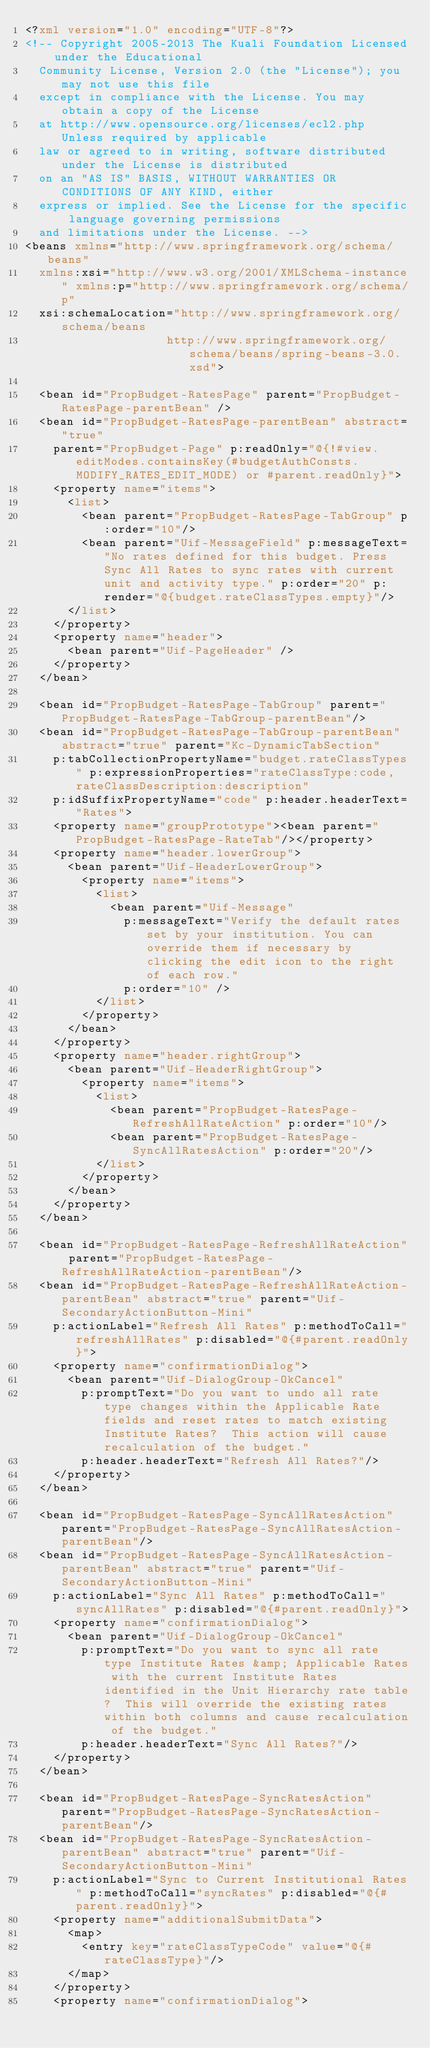Convert code to text. <code><loc_0><loc_0><loc_500><loc_500><_XML_><?xml version="1.0" encoding="UTF-8"?>
<!-- Copyright 2005-2013 The Kuali Foundation Licensed under the Educational 
	Community License, Version 2.0 (the "License"); you may not use this file 
	except in compliance with the License. You may obtain a copy of the License 
	at http://www.opensource.org/licenses/ecl2.php Unless required by applicable 
	law or agreed to in writing, software distributed under the License is distributed 
	on an "AS IS" BASIS, WITHOUT WARRANTIES OR CONDITIONS OF ANY KIND, either 
	express or implied. See the License for the specific language governing permissions 
	and limitations under the License. -->
<beans xmlns="http://www.springframework.org/schema/beans"
	xmlns:xsi="http://www.w3.org/2001/XMLSchema-instance" xmlns:p="http://www.springframework.org/schema/p"
	xsi:schemaLocation="http://www.springframework.org/schema/beans
                    http://www.springframework.org/schema/beans/spring-beans-3.0.xsd">

	<bean id="PropBudget-RatesPage" parent="PropBudget-RatesPage-parentBean" />
	<bean id="PropBudget-RatesPage-parentBean" abstract="true"
		parent="PropBudget-Page" p:readOnly="@{!#view.editModes.containsKey(#budgetAuthConsts.MODIFY_RATES_EDIT_MODE) or #parent.readOnly}">
		<property name="items">
			<list>
				<bean parent="PropBudget-RatesPage-TabGroup" p:order="10"/>
				<bean parent="Uif-MessageField" p:messageText="No rates defined for this budget. Press Sync All Rates to sync rates with current unit and activity type." p:order="20" p:render="@{budget.rateClassTypes.empty}"/>
			</list>
		</property>
		<property name="header">
			<bean parent="Uif-PageHeader" />
		</property>
	</bean>

	<bean id="PropBudget-RatesPage-TabGroup" parent="PropBudget-RatesPage-TabGroup-parentBean"/>
	<bean id="PropBudget-RatesPage-TabGroup-parentBean" abstract="true" parent="Kc-DynamicTabSection"
		p:tabCollectionPropertyName="budget.rateClassTypes" p:expressionProperties="rateClassType:code,rateClassDescription:description"
		p:idSuffixPropertyName="code" p:header.headerText="Rates">
		<property name="groupPrototype"><bean parent="PropBudget-RatesPage-RateTab"/></property>
		<property name="header.lowerGroup">
			<bean parent="Uif-HeaderLowerGroup">
				<property name="items">
					<list>
						<bean parent="Uif-Message"
							p:messageText="Verify the default rates set by your institution. You can override them if necessary by clicking the edit icon to the right of each row."
							p:order="10" />
					</list>
				</property>
			</bean>
		</property>
		<property name="header.rightGroup">
			<bean parent="Uif-HeaderRightGroup">
				<property name="items">
					<list>
						<bean parent="PropBudget-RatesPage-RefreshAllRateAction" p:order="10"/>
						<bean parent="PropBudget-RatesPage-SyncAllRatesAction" p:order="20"/>
					</list>
				</property>
			</bean>
		</property>		
	</bean>
	
	<bean id="PropBudget-RatesPage-RefreshAllRateAction" parent="PropBudget-RatesPage-RefreshAllRateAction-parentBean"/>
	<bean id="PropBudget-RatesPage-RefreshAllRateAction-parentBean" abstract="true" parent="Uif-SecondaryActionButton-Mini" 
		p:actionLabel="Refresh All Rates" p:methodToCall="refreshAllRates" p:disabled="@{#parent.readOnly}">
		<property name="confirmationDialog">
			<bean parent="Uif-DialogGroup-OkCancel"
				p:promptText="Do you want to undo all rate type changes within the Applicable Rate fields and reset rates to match existing Institute Rates?  This action will cause recalculation of the budget."
				p:header.headerText="Refresh All Rates?"/>
		</property>
	</bean>
	
	<bean id="PropBudget-RatesPage-SyncAllRatesAction" parent="PropBudget-RatesPage-SyncAllRatesAction-parentBean"/>
	<bean id="PropBudget-RatesPage-SyncAllRatesAction-parentBean" abstract="true" parent="Uif-SecondaryActionButton-Mini" 
		p:actionLabel="Sync All Rates" p:methodToCall="syncAllRates" p:disabled="@{#parent.readOnly}">
		<property name="confirmationDialog">
			<bean parent="Uif-DialogGroup-OkCancel" 
				p:promptText="Do you want to sync all rate type Institute Rates &amp; Applicable Rates with the current Institute Rates identified in the Unit Hierarchy rate table?  This will override the existing rates within both columns and cause recalculation of the budget."
				p:header.headerText="Sync All Rates?"/>
		</property>							
	</bean>
	
	<bean id="PropBudget-RatesPage-SyncRatesAction" parent="PropBudget-RatesPage-SyncRatesAction-parentBean"/>
	<bean id="PropBudget-RatesPage-SyncRatesAction-parentBean" abstract="true" parent="Uif-SecondaryActionButton-Mini" 
		p:actionLabel="Sync to Current Institutional Rates" p:methodToCall="syncRates" p:disabled="@{#parent.readOnly}">
		<property name="additionalSubmitData">
			<map>
				<entry key="rateClassTypeCode" value="@{#rateClassType}"/>
			</map>
		</property>
		<property name="confirmationDialog"></code> 